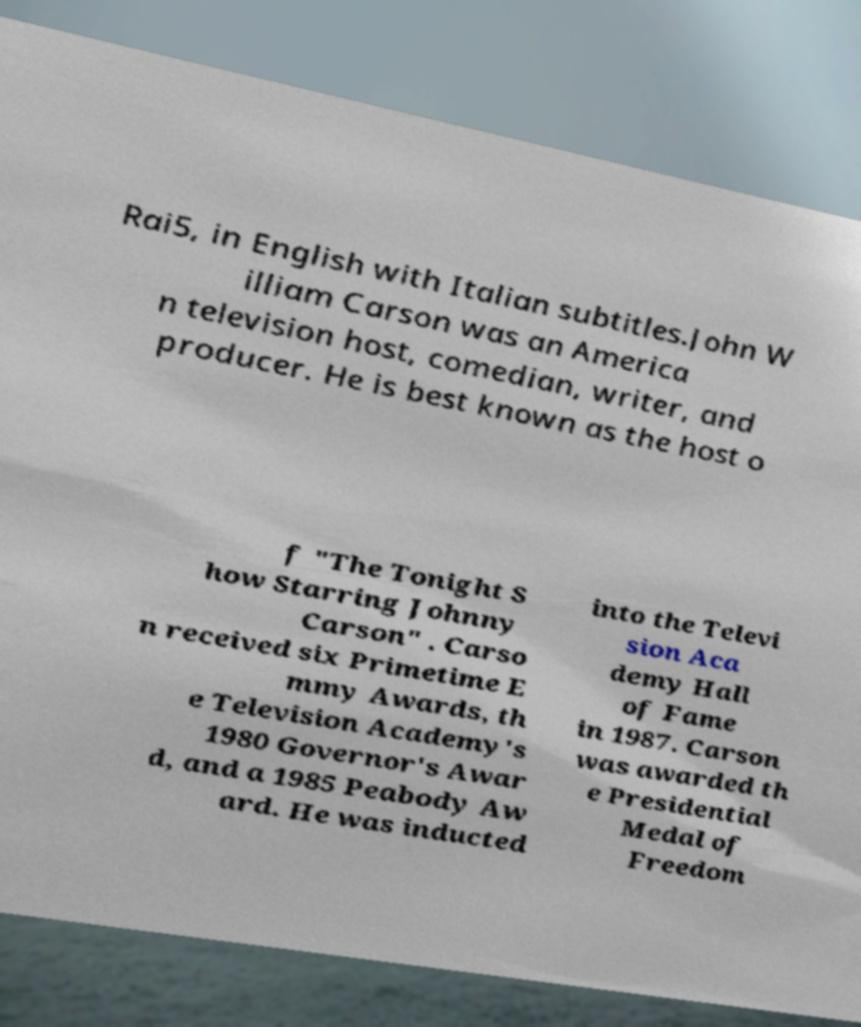Could you extract and type out the text from this image? Rai5, in English with Italian subtitles.John W illiam Carson was an America n television host, comedian, writer, and producer. He is best known as the host o f "The Tonight S how Starring Johnny Carson" . Carso n received six Primetime E mmy Awards, th e Television Academy's 1980 Governor's Awar d, and a 1985 Peabody Aw ard. He was inducted into the Televi sion Aca demy Hall of Fame in 1987. Carson was awarded th e Presidential Medal of Freedom 